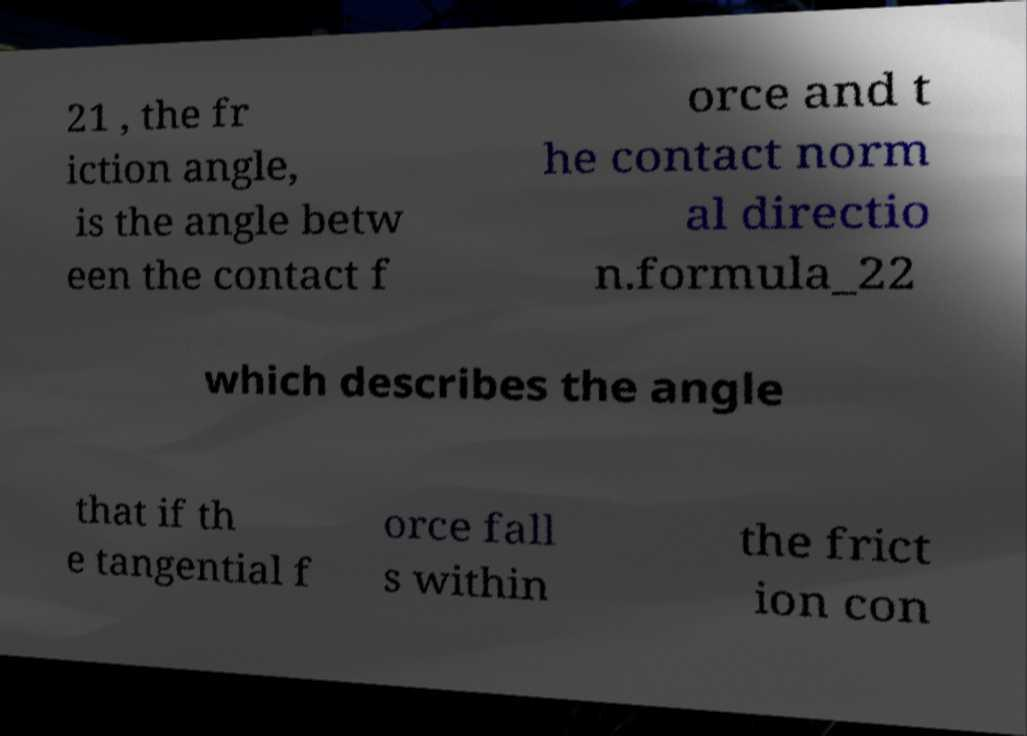Please identify and transcribe the text found in this image. 21 , the fr iction angle, is the angle betw een the contact f orce and t he contact norm al directio n.formula_22 which describes the angle that if th e tangential f orce fall s within the frict ion con 